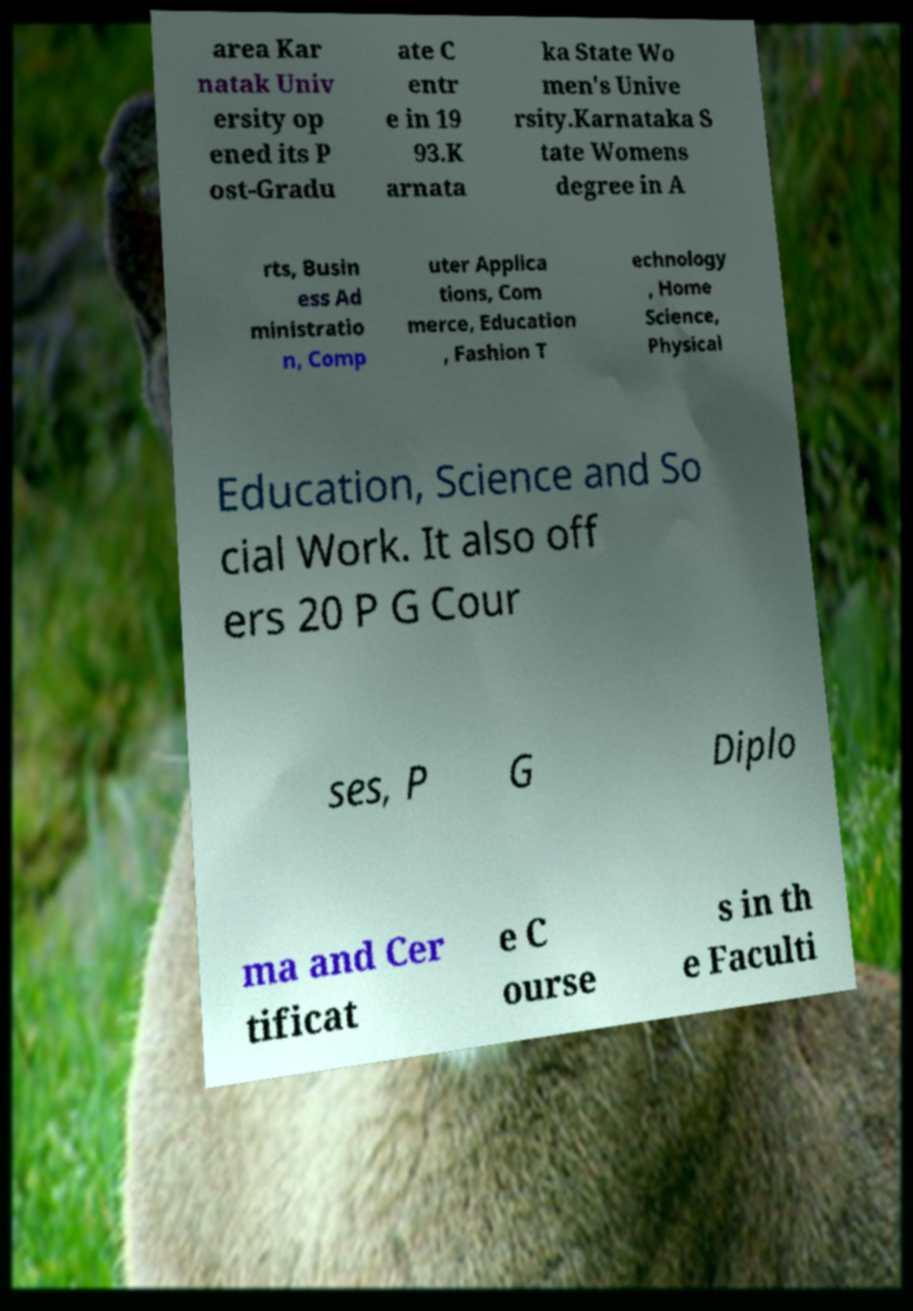Please read and relay the text visible in this image. What does it say? area Kar natak Univ ersity op ened its P ost-Gradu ate C entr e in 19 93.K arnata ka State Wo men's Unive rsity.Karnataka S tate Womens degree in A rts, Busin ess Ad ministratio n, Comp uter Applica tions, Com merce, Education , Fashion T echnology , Home Science, Physical Education, Science and So cial Work. It also off ers 20 P G Cour ses, P G Diplo ma and Cer tificat e C ourse s in th e Faculti 